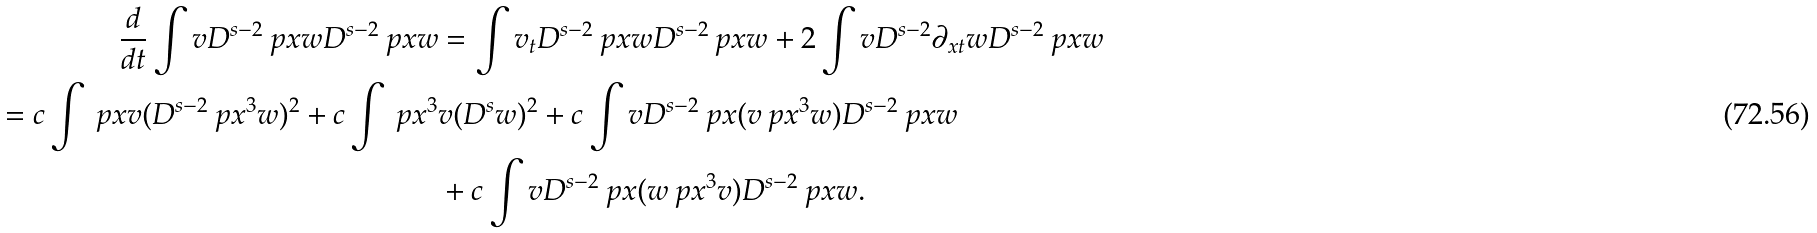<formula> <loc_0><loc_0><loc_500><loc_500>\frac { d } { d t } \int v D ^ { s - 2 } \ p x w D ^ { s - 2 } \ p x w & = \int v _ { t } D ^ { s - 2 } \ p x w D ^ { s - 2 } \ p x w + 2 \int v D ^ { s - 2 } \partial _ { x t } w D ^ { s - 2 } \ p x w \\ = c \int \ p x v ( D ^ { s - 2 } \ p x ^ { 3 } w ) ^ { 2 } + c \int \ p x ^ { 3 } & v ( D ^ { s } w ) ^ { 2 } + c \int v D ^ { s - 2 } \ p x ( v \ p x ^ { 3 } w ) D ^ { s - 2 } \ p x w \\ & + c \int v D ^ { s - 2 } \ p x ( w \ p x ^ { 3 } v ) D ^ { s - 2 } \ p x w .</formula> 